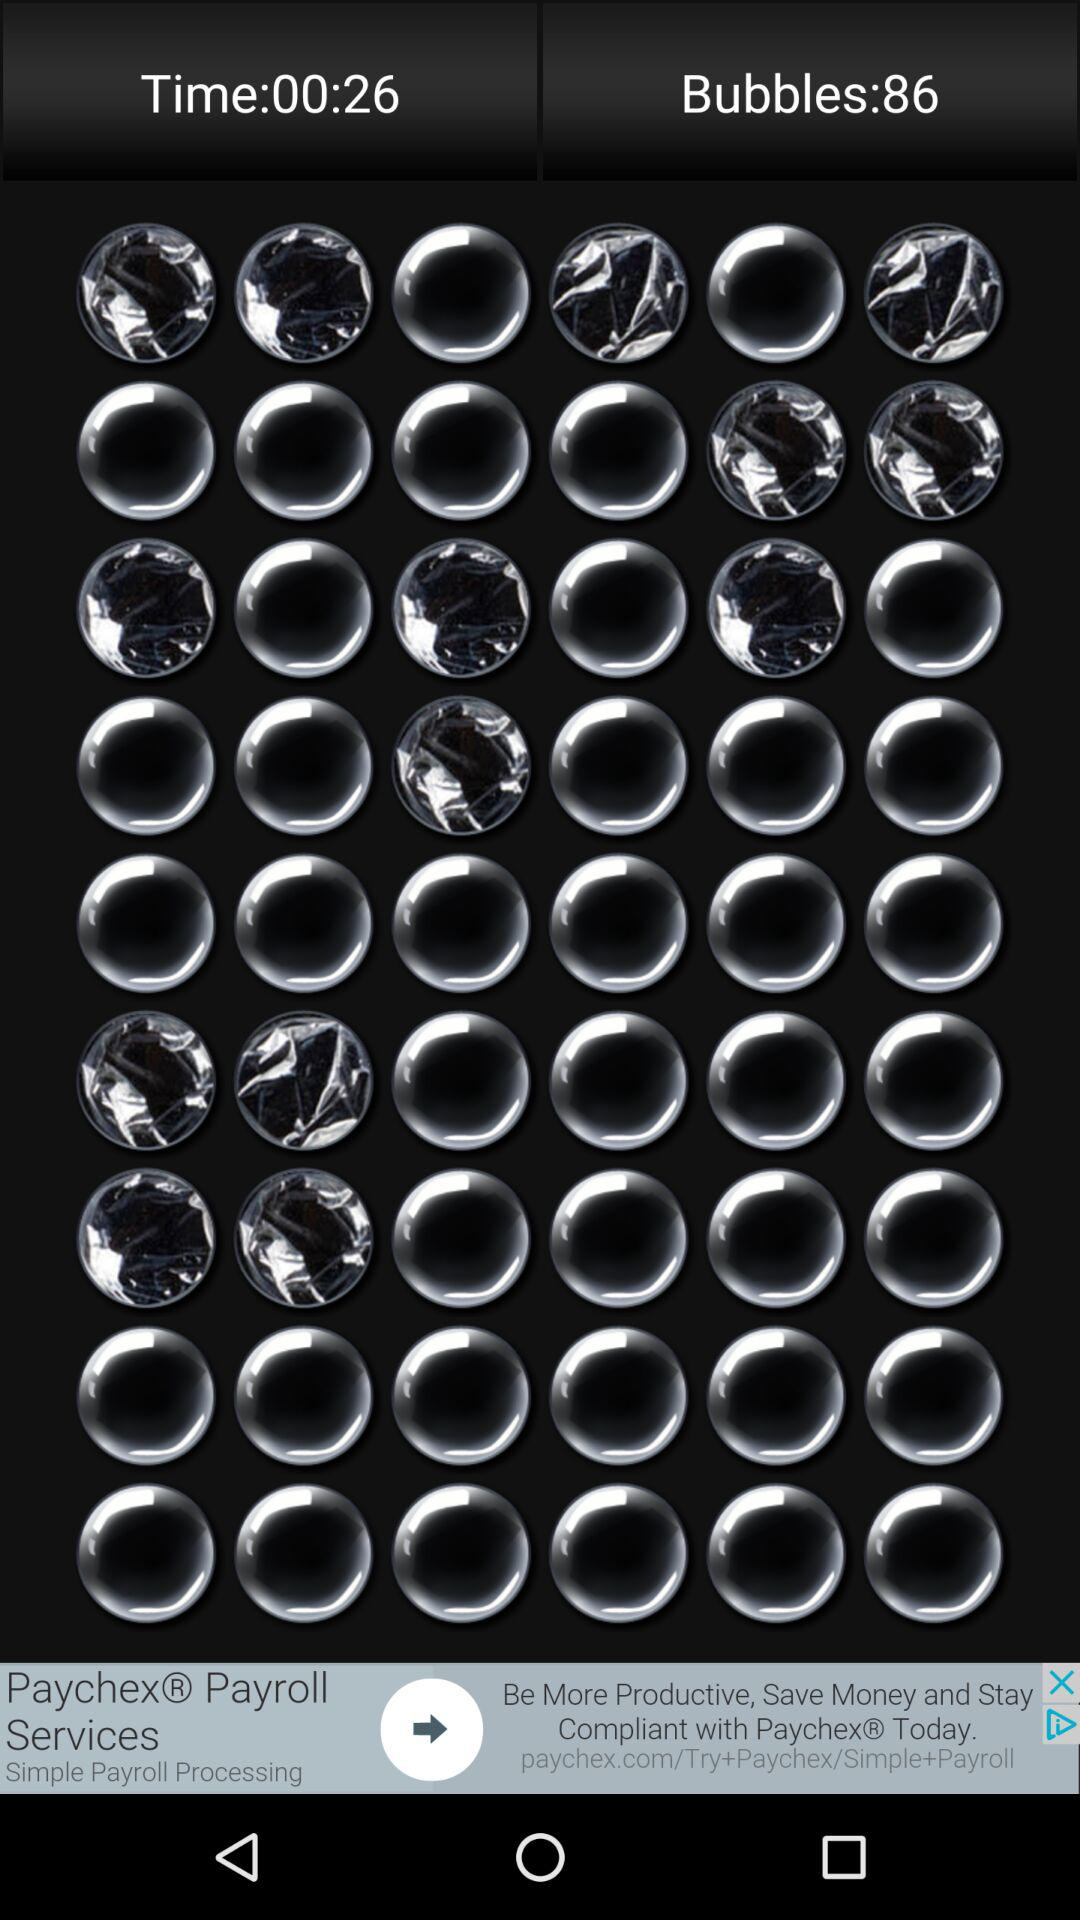How many bubbles are there? There are 86 bubbles. 